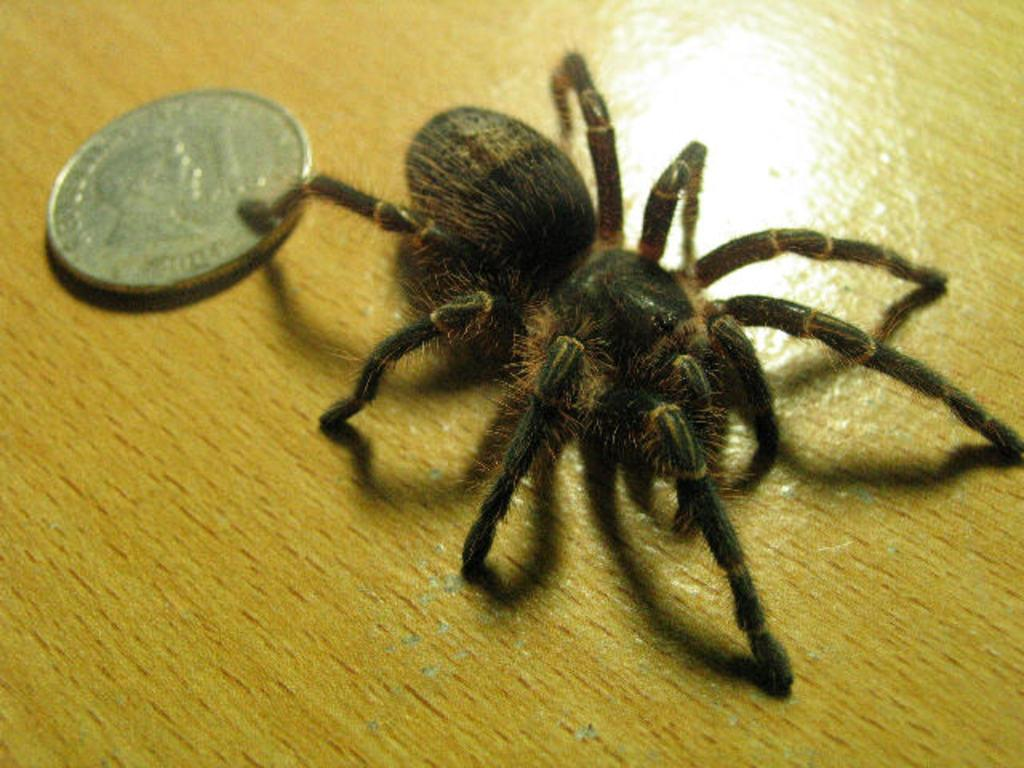What is the main subject of the image? The main subject of the image is a spider. What other object can be seen in the image? There is a coin in the image. Where is the coin located? The coin is on a table. Can you tell me how many people are in the crowd surrounding the spider and coin in the image? There is no crowd present in the image; it only features a spider and a coin. What type of earth is visible beneath the spider and coin in the image? There is no earth visible in the image; it is not a photograph taken from a great height. 